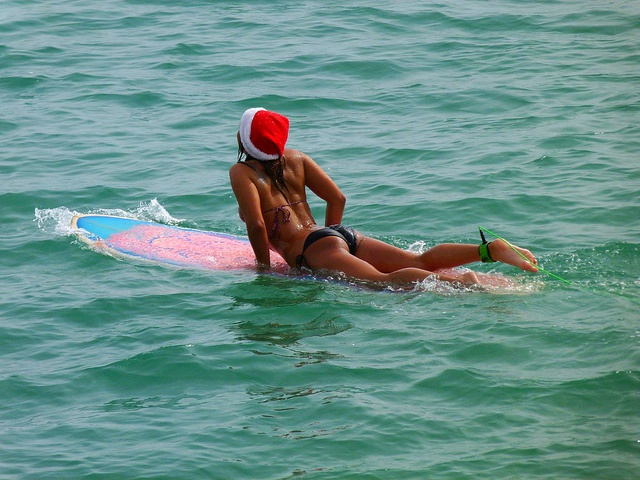Describe the objects in this image and their specific colors. I can see people in lightblue, maroon, black, and brown tones and surfboard in lightblue, pink, and lightpink tones in this image. 